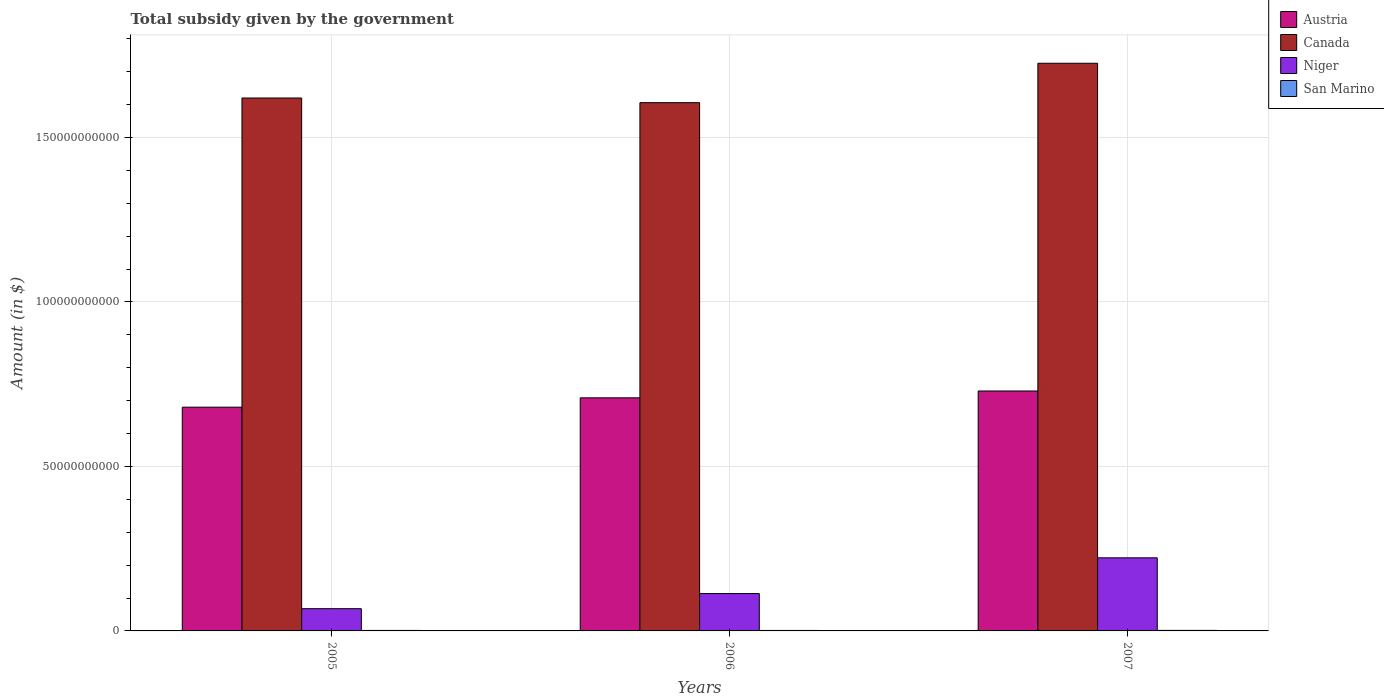How many groups of bars are there?
Your answer should be compact. 3. Are the number of bars on each tick of the X-axis equal?
Give a very brief answer. Yes. How many bars are there on the 2nd tick from the left?
Your answer should be compact. 4. What is the label of the 1st group of bars from the left?
Keep it short and to the point. 2005. In how many cases, is the number of bars for a given year not equal to the number of legend labels?
Provide a succinct answer. 0. What is the total revenue collected by the government in Niger in 2006?
Offer a terse response. 1.14e+1. Across all years, what is the maximum total revenue collected by the government in Austria?
Offer a terse response. 7.29e+1. Across all years, what is the minimum total revenue collected by the government in Canada?
Give a very brief answer. 1.61e+11. What is the total total revenue collected by the government in San Marino in the graph?
Offer a very short reply. 4.56e+08. What is the difference between the total revenue collected by the government in San Marino in 2006 and that in 2007?
Make the answer very short. -1.87e+07. What is the difference between the total revenue collected by the government in Canada in 2007 and the total revenue collected by the government in San Marino in 2006?
Your answer should be very brief. 1.72e+11. What is the average total revenue collected by the government in San Marino per year?
Offer a very short reply. 1.52e+08. In the year 2005, what is the difference between the total revenue collected by the government in San Marino and total revenue collected by the government in Austria?
Your answer should be very brief. -6.79e+1. What is the ratio of the total revenue collected by the government in Austria in 2005 to that in 2007?
Give a very brief answer. 0.93. Is the total revenue collected by the government in Canada in 2005 less than that in 2006?
Give a very brief answer. No. What is the difference between the highest and the second highest total revenue collected by the government in Canada?
Give a very brief answer. 1.06e+1. What is the difference between the highest and the lowest total revenue collected by the government in San Marino?
Offer a very short reply. 1.87e+07. In how many years, is the total revenue collected by the government in Canada greater than the average total revenue collected by the government in Canada taken over all years?
Offer a terse response. 1. Is the sum of the total revenue collected by the government in Austria in 2005 and 2006 greater than the maximum total revenue collected by the government in San Marino across all years?
Give a very brief answer. Yes. What does the 2nd bar from the left in 2007 represents?
Keep it short and to the point. Canada. What does the 2nd bar from the right in 2007 represents?
Provide a short and direct response. Niger. How many legend labels are there?
Ensure brevity in your answer.  4. How are the legend labels stacked?
Give a very brief answer. Vertical. What is the title of the graph?
Your answer should be very brief. Total subsidy given by the government. What is the label or title of the Y-axis?
Keep it short and to the point. Amount (in $). What is the Amount (in $) of Austria in 2005?
Your response must be concise. 6.80e+1. What is the Amount (in $) in Canada in 2005?
Your response must be concise. 1.62e+11. What is the Amount (in $) in Niger in 2005?
Provide a succinct answer. 6.76e+09. What is the Amount (in $) of San Marino in 2005?
Make the answer very short. 1.49e+08. What is the Amount (in $) of Austria in 2006?
Give a very brief answer. 7.09e+1. What is the Amount (in $) of Canada in 2006?
Offer a terse response. 1.61e+11. What is the Amount (in $) of Niger in 2006?
Make the answer very short. 1.14e+1. What is the Amount (in $) in San Marino in 2006?
Provide a succinct answer. 1.44e+08. What is the Amount (in $) in Austria in 2007?
Offer a terse response. 7.29e+1. What is the Amount (in $) of Canada in 2007?
Give a very brief answer. 1.73e+11. What is the Amount (in $) of Niger in 2007?
Provide a succinct answer. 2.22e+1. What is the Amount (in $) in San Marino in 2007?
Provide a short and direct response. 1.63e+08. Across all years, what is the maximum Amount (in $) of Austria?
Offer a terse response. 7.29e+1. Across all years, what is the maximum Amount (in $) in Canada?
Offer a very short reply. 1.73e+11. Across all years, what is the maximum Amount (in $) in Niger?
Your response must be concise. 2.22e+1. Across all years, what is the maximum Amount (in $) in San Marino?
Your answer should be very brief. 1.63e+08. Across all years, what is the minimum Amount (in $) of Austria?
Make the answer very short. 6.80e+1. Across all years, what is the minimum Amount (in $) of Canada?
Give a very brief answer. 1.61e+11. Across all years, what is the minimum Amount (in $) of Niger?
Provide a short and direct response. 6.76e+09. Across all years, what is the minimum Amount (in $) of San Marino?
Offer a terse response. 1.44e+08. What is the total Amount (in $) of Austria in the graph?
Ensure brevity in your answer.  2.12e+11. What is the total Amount (in $) of Canada in the graph?
Provide a short and direct response. 4.95e+11. What is the total Amount (in $) in Niger in the graph?
Make the answer very short. 4.03e+1. What is the total Amount (in $) of San Marino in the graph?
Provide a succinct answer. 4.56e+08. What is the difference between the Amount (in $) of Austria in 2005 and that in 2006?
Your response must be concise. -2.85e+09. What is the difference between the Amount (in $) in Canada in 2005 and that in 2006?
Keep it short and to the point. 1.41e+09. What is the difference between the Amount (in $) of Niger in 2005 and that in 2006?
Offer a terse response. -4.59e+09. What is the difference between the Amount (in $) in San Marino in 2005 and that in 2006?
Make the answer very short. 4.95e+06. What is the difference between the Amount (in $) of Austria in 2005 and that in 2007?
Offer a very short reply. -4.92e+09. What is the difference between the Amount (in $) of Canada in 2005 and that in 2007?
Make the answer very short. -1.06e+1. What is the difference between the Amount (in $) in Niger in 2005 and that in 2007?
Offer a very short reply. -1.55e+1. What is the difference between the Amount (in $) in San Marino in 2005 and that in 2007?
Ensure brevity in your answer.  -1.38e+07. What is the difference between the Amount (in $) of Austria in 2006 and that in 2007?
Make the answer very short. -2.08e+09. What is the difference between the Amount (in $) of Canada in 2006 and that in 2007?
Your answer should be compact. -1.20e+1. What is the difference between the Amount (in $) in Niger in 2006 and that in 2007?
Provide a short and direct response. -1.09e+1. What is the difference between the Amount (in $) in San Marino in 2006 and that in 2007?
Make the answer very short. -1.87e+07. What is the difference between the Amount (in $) in Austria in 2005 and the Amount (in $) in Canada in 2006?
Offer a terse response. -9.26e+1. What is the difference between the Amount (in $) in Austria in 2005 and the Amount (in $) in Niger in 2006?
Offer a very short reply. 5.67e+1. What is the difference between the Amount (in $) of Austria in 2005 and the Amount (in $) of San Marino in 2006?
Offer a very short reply. 6.79e+1. What is the difference between the Amount (in $) of Canada in 2005 and the Amount (in $) of Niger in 2006?
Your answer should be compact. 1.51e+11. What is the difference between the Amount (in $) in Canada in 2005 and the Amount (in $) in San Marino in 2006?
Provide a short and direct response. 1.62e+11. What is the difference between the Amount (in $) of Niger in 2005 and the Amount (in $) of San Marino in 2006?
Ensure brevity in your answer.  6.62e+09. What is the difference between the Amount (in $) in Austria in 2005 and the Amount (in $) in Canada in 2007?
Your answer should be compact. -1.05e+11. What is the difference between the Amount (in $) of Austria in 2005 and the Amount (in $) of Niger in 2007?
Provide a short and direct response. 4.58e+1. What is the difference between the Amount (in $) in Austria in 2005 and the Amount (in $) in San Marino in 2007?
Your response must be concise. 6.78e+1. What is the difference between the Amount (in $) of Canada in 2005 and the Amount (in $) of Niger in 2007?
Offer a terse response. 1.40e+11. What is the difference between the Amount (in $) of Canada in 2005 and the Amount (in $) of San Marino in 2007?
Your response must be concise. 1.62e+11. What is the difference between the Amount (in $) of Niger in 2005 and the Amount (in $) of San Marino in 2007?
Provide a succinct answer. 6.60e+09. What is the difference between the Amount (in $) of Austria in 2006 and the Amount (in $) of Canada in 2007?
Your answer should be compact. -1.02e+11. What is the difference between the Amount (in $) in Austria in 2006 and the Amount (in $) in Niger in 2007?
Make the answer very short. 4.86e+1. What is the difference between the Amount (in $) in Austria in 2006 and the Amount (in $) in San Marino in 2007?
Your response must be concise. 7.07e+1. What is the difference between the Amount (in $) of Canada in 2006 and the Amount (in $) of Niger in 2007?
Offer a terse response. 1.38e+11. What is the difference between the Amount (in $) in Canada in 2006 and the Amount (in $) in San Marino in 2007?
Make the answer very short. 1.60e+11. What is the difference between the Amount (in $) of Niger in 2006 and the Amount (in $) of San Marino in 2007?
Make the answer very short. 1.12e+1. What is the average Amount (in $) in Austria per year?
Make the answer very short. 7.06e+1. What is the average Amount (in $) in Canada per year?
Ensure brevity in your answer.  1.65e+11. What is the average Amount (in $) of Niger per year?
Make the answer very short. 1.34e+1. What is the average Amount (in $) of San Marino per year?
Your answer should be compact. 1.52e+08. In the year 2005, what is the difference between the Amount (in $) of Austria and Amount (in $) of Canada?
Your answer should be compact. -9.40e+1. In the year 2005, what is the difference between the Amount (in $) of Austria and Amount (in $) of Niger?
Your answer should be very brief. 6.12e+1. In the year 2005, what is the difference between the Amount (in $) of Austria and Amount (in $) of San Marino?
Offer a very short reply. 6.79e+1. In the year 2005, what is the difference between the Amount (in $) in Canada and Amount (in $) in Niger?
Offer a terse response. 1.55e+11. In the year 2005, what is the difference between the Amount (in $) of Canada and Amount (in $) of San Marino?
Provide a succinct answer. 1.62e+11. In the year 2005, what is the difference between the Amount (in $) of Niger and Amount (in $) of San Marino?
Provide a short and direct response. 6.61e+09. In the year 2006, what is the difference between the Amount (in $) in Austria and Amount (in $) in Canada?
Make the answer very short. -8.97e+1. In the year 2006, what is the difference between the Amount (in $) in Austria and Amount (in $) in Niger?
Ensure brevity in your answer.  5.95e+1. In the year 2006, what is the difference between the Amount (in $) in Austria and Amount (in $) in San Marino?
Offer a terse response. 7.07e+1. In the year 2006, what is the difference between the Amount (in $) of Canada and Amount (in $) of Niger?
Ensure brevity in your answer.  1.49e+11. In the year 2006, what is the difference between the Amount (in $) of Canada and Amount (in $) of San Marino?
Ensure brevity in your answer.  1.60e+11. In the year 2006, what is the difference between the Amount (in $) of Niger and Amount (in $) of San Marino?
Make the answer very short. 1.12e+1. In the year 2007, what is the difference between the Amount (in $) of Austria and Amount (in $) of Canada?
Offer a very short reply. -9.96e+1. In the year 2007, what is the difference between the Amount (in $) of Austria and Amount (in $) of Niger?
Offer a terse response. 5.07e+1. In the year 2007, what is the difference between the Amount (in $) of Austria and Amount (in $) of San Marino?
Provide a succinct answer. 7.28e+1. In the year 2007, what is the difference between the Amount (in $) of Canada and Amount (in $) of Niger?
Keep it short and to the point. 1.50e+11. In the year 2007, what is the difference between the Amount (in $) in Canada and Amount (in $) in San Marino?
Provide a succinct answer. 1.72e+11. In the year 2007, what is the difference between the Amount (in $) of Niger and Amount (in $) of San Marino?
Provide a succinct answer. 2.21e+1. What is the ratio of the Amount (in $) in Austria in 2005 to that in 2006?
Provide a short and direct response. 0.96. What is the ratio of the Amount (in $) in Canada in 2005 to that in 2006?
Ensure brevity in your answer.  1.01. What is the ratio of the Amount (in $) of Niger in 2005 to that in 2006?
Your response must be concise. 0.6. What is the ratio of the Amount (in $) of San Marino in 2005 to that in 2006?
Your response must be concise. 1.03. What is the ratio of the Amount (in $) in Austria in 2005 to that in 2007?
Keep it short and to the point. 0.93. What is the ratio of the Amount (in $) in Canada in 2005 to that in 2007?
Give a very brief answer. 0.94. What is the ratio of the Amount (in $) in Niger in 2005 to that in 2007?
Keep it short and to the point. 0.3. What is the ratio of the Amount (in $) in San Marino in 2005 to that in 2007?
Your answer should be compact. 0.92. What is the ratio of the Amount (in $) in Austria in 2006 to that in 2007?
Provide a short and direct response. 0.97. What is the ratio of the Amount (in $) of Canada in 2006 to that in 2007?
Make the answer very short. 0.93. What is the ratio of the Amount (in $) in Niger in 2006 to that in 2007?
Your answer should be very brief. 0.51. What is the ratio of the Amount (in $) in San Marino in 2006 to that in 2007?
Your response must be concise. 0.89. What is the difference between the highest and the second highest Amount (in $) of Austria?
Your answer should be very brief. 2.08e+09. What is the difference between the highest and the second highest Amount (in $) of Canada?
Give a very brief answer. 1.06e+1. What is the difference between the highest and the second highest Amount (in $) in Niger?
Your answer should be very brief. 1.09e+1. What is the difference between the highest and the second highest Amount (in $) of San Marino?
Make the answer very short. 1.38e+07. What is the difference between the highest and the lowest Amount (in $) of Austria?
Offer a terse response. 4.92e+09. What is the difference between the highest and the lowest Amount (in $) in Canada?
Offer a very short reply. 1.20e+1. What is the difference between the highest and the lowest Amount (in $) in Niger?
Offer a terse response. 1.55e+1. What is the difference between the highest and the lowest Amount (in $) of San Marino?
Give a very brief answer. 1.87e+07. 